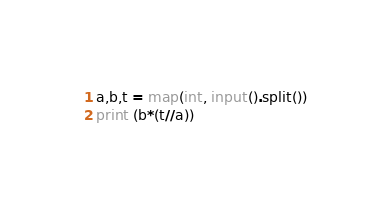<code> <loc_0><loc_0><loc_500><loc_500><_Python_>a,b,t = map(int, input().split())
print (b*(t//a))</code> 